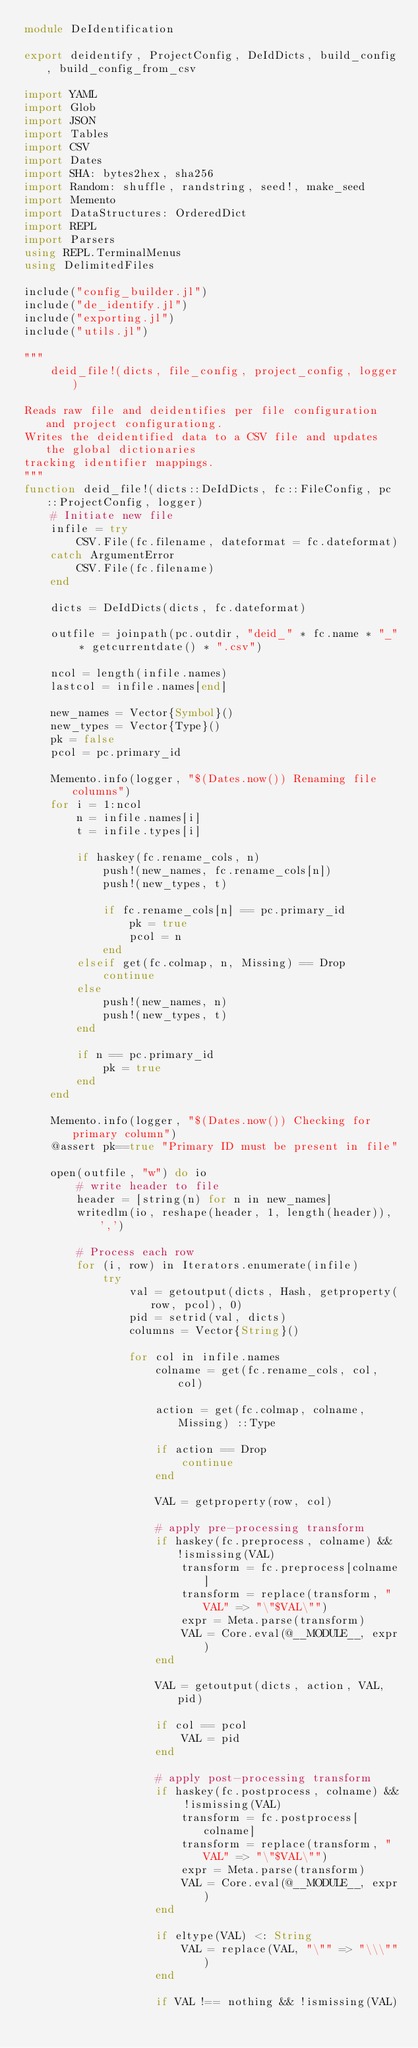Convert code to text. <code><loc_0><loc_0><loc_500><loc_500><_Julia_>module DeIdentification

export deidentify, ProjectConfig, DeIdDicts, build_config, build_config_from_csv

import YAML
import Glob
import JSON
import Tables
import CSV
import Dates
import SHA: bytes2hex, sha256
import Random: shuffle, randstring, seed!, make_seed
import Memento
import DataStructures: OrderedDict
import REPL
import Parsers
using REPL.TerminalMenus
using DelimitedFiles

include("config_builder.jl")
include("de_identify.jl")
include("exporting.jl")
include("utils.jl")

"""
    deid_file!(dicts, file_config, project_config, logger)

Reads raw file and deidentifies per file configuration and project configurationg.
Writes the deidentified data to a CSV file and updates the global dictionaries
tracking identifier mappings.
"""
function deid_file!(dicts::DeIdDicts, fc::FileConfig, pc::ProjectConfig, logger)
    # Initiate new file
    infile = try
        CSV.File(fc.filename, dateformat = fc.dateformat)
    catch ArgumentError
        CSV.File(fc.filename)
    end

    dicts = DeIdDicts(dicts, fc.dateformat)

    outfile = joinpath(pc.outdir, "deid_" * fc.name * "_" * getcurrentdate() * ".csv")

    ncol = length(infile.names)
    lastcol = infile.names[end]

    new_names = Vector{Symbol}()
    new_types = Vector{Type}()
    pk = false
    pcol = pc.primary_id

    Memento.info(logger, "$(Dates.now()) Renaming file columns")
    for i = 1:ncol
        n = infile.names[i]
        t = infile.types[i]

        if haskey(fc.rename_cols, n)
            push!(new_names, fc.rename_cols[n])
            push!(new_types, t)

            if fc.rename_cols[n] == pc.primary_id
                pk = true
                pcol = n
            end
        elseif get(fc.colmap, n, Missing) == Drop
            continue
        else
            push!(new_names, n)
            push!(new_types, t)
        end

        if n == pc.primary_id
            pk = true
        end
    end

    Memento.info(logger, "$(Dates.now()) Checking for primary column")
    @assert pk==true "Primary ID must be present in file"

    open(outfile, "w") do io
        # write header to file
        header = [string(n) for n in new_names]
        writedlm(io, reshape(header, 1, length(header)), ',')

        # Process each row
        for (i, row) in Iterators.enumerate(infile)
            try
                val = getoutput(dicts, Hash, getproperty(row, pcol), 0)
                pid = setrid(val, dicts)
                columns = Vector{String}()

                for col in infile.names
                    colname = get(fc.rename_cols, col, col)

                    action = get(fc.colmap, colname, Missing) ::Type

                    if action == Drop
                        continue
                    end

                    VAL = getproperty(row, col)

                    # apply pre-processing transform
                    if haskey(fc.preprocess, colname) && !ismissing(VAL)
                        transform = fc.preprocess[colname]
                        transform = replace(transform, "VAL" => "\"$VAL\"")
                        expr = Meta.parse(transform)
                        VAL = Core.eval(@__MODULE__, expr)
                    end

                    VAL = getoutput(dicts, action, VAL, pid)

                    if col == pcol
                        VAL = pid
                    end

                    # apply post-processing transform
                    if haskey(fc.postprocess, colname) && !ismissing(VAL)
                        transform = fc.postprocess[colname]
                        transform = replace(transform, "VAL" => "\"$VAL\"")
                        expr = Meta.parse(transform)
                        VAL = Core.eval(@__MODULE__, expr)
                    end

                    if eltype(VAL) <: String
                        VAL = replace(VAL, "\"" => "\\\"")
                    end

                    if VAL !== nothing && !ismissing(VAL)</code> 